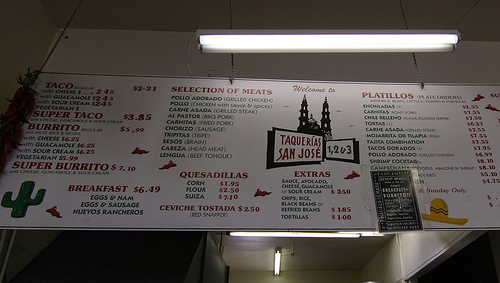<image>
Is there a light on the menu? Yes. Looking at the image, I can see the light is positioned on top of the menu, with the menu providing support. Where is the light in relation to the sign? Is it behind the sign? Yes. From this viewpoint, the light is positioned behind the sign, with the sign partially or fully occluding the light. 